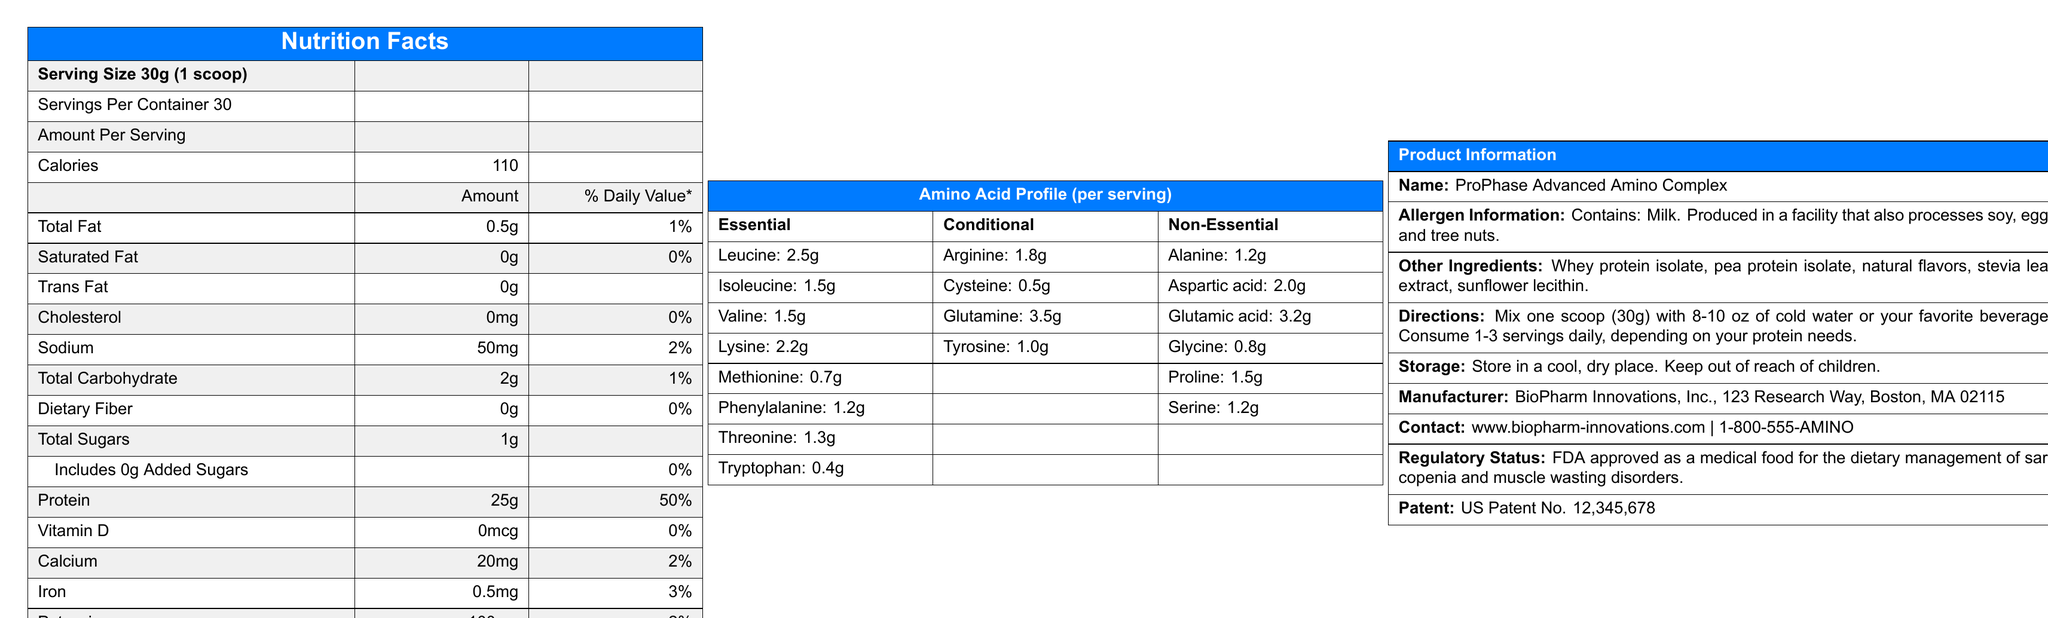what is the serving size for ProPhase Advanced Amino Complex? The document states that the serving size is 30g, which is equivalent to 1 scoop.
Answer: 30g (1 scoop) how many servings are in each container? The document specifies that each container contains 30 servings.
Answer: 30 how many calories are there per serving of ProPhase Advanced Amino Complex? According to the document, each serving has 110 calories.
Answer: 110 what is the amount of protein per serving? The nutrition facts label indicates that there are 25g of protein per serving.
Answer: 25g what percentage of the daily value of iron does one serving provide? The document mentions that one serving provides 3% of the daily value for iron.
Answer: 3% what allergens are present in ProPhase Advanced Amino Complex? The allergen information section states that the product contains milk.
Answer: Milk how much sodium is in each serving? The nutrition facts section lists sodium as 50mg per serving.
Answer: 50mg does ProPhase Advanced Amino Complex contain any added sugars? The document states that there are 0g of added sugars.
Answer: No what are the main ingredients in ProPhase Advanced Amino Complex? The other ingredients section lists these as the primary ingredients.
Answer: Whey protein isolate, pea protein isolate, natural flavors, stevia leaf extract, sunflower lecithin what is the total amount of carbohydrates per serving? The nutrition facts label indicates that there are 2g of total carbohydrates per serving.
Answer: 2g where is BioPharm Innovations, Inc. located? The manufacturer information section provides the address.
Answer: 123 Research Way, Boston, MA 02115 what is the regulatory status of ProPhase Advanced Amino Complex? The document states this regulatory status under the Product Information section.
Answer: FDA approved as a medical food for the dietary management of sarcopenia and muscle wasting disorders how should ProPhase Advanced Amino Complex be stored? The storage instructions specify these conditions.
Answer: In a cool, dry place and out of reach of children which essential amino acid is present in the highest amount per serving? A. Lysine B. Leucine C. Threonine D. Tryptophan The amino acid profile shows that leucine is present in the highest amount among essential amino acids, with 2.5g per serving.
Answer: B. Leucine which of the following is not part of the amino acid profile in ProPhase Advanced Amino Complex? 1. Glutamine 2. Alanine 3. Serine 4. Histidine The amino acid profile does not list histidine, whereas all other options are listed.
Answer: 4. Histidine is ProPhase Advanced Amino Complex suitable for people with tree nut allergies? The document states that it is produced in a facility that also processes tree nuts, which may not be safe for people with tree nut allergies.
Answer: No summarize the main purpose and content of the ProPhase Advanced Amino Complex document. This summary encapsulates the primary details and purpose of the document, highlighting its nutritional and pharmaceutical importance.
Answer: The document provides comprehensive nutritional information about ProPhase Advanced Amino Complex, a pharmaceutical protein supplement designed to enhance muscle protein synthesis and recovery. It includes details on serving size, nutritional content, amino acid profile, allergens, ingredients, usage directions, storage instructions, manufacturer details, and regulatory status. The product is FDA approved for managing sarcopenia and muscle wasting disorders and showcases a detailed amino acid profile to optimize muscle recovery. how much trans fat is in ProPhase Advanced Amino Complex? The document states that there is no trans fat in a serving.
Answer: 0g how much vitamin D does each serving of ProPhase Advanced Amino Complex provide? According to the nutrition facts, there is no vitamin D in each serving.
Answer: 0mcg is the patent information for ProPhase Advanced Amino Complex included in the document? The document includes patent information, indicating US Patent No. 12,345,678.
Answer: Yes what method was used in the development of this protein supplement? While the document mentions "advanced recombinant DNA technology," specific details about the method cannot be fully determined from the provided information.
Answer: Cannot be determined 